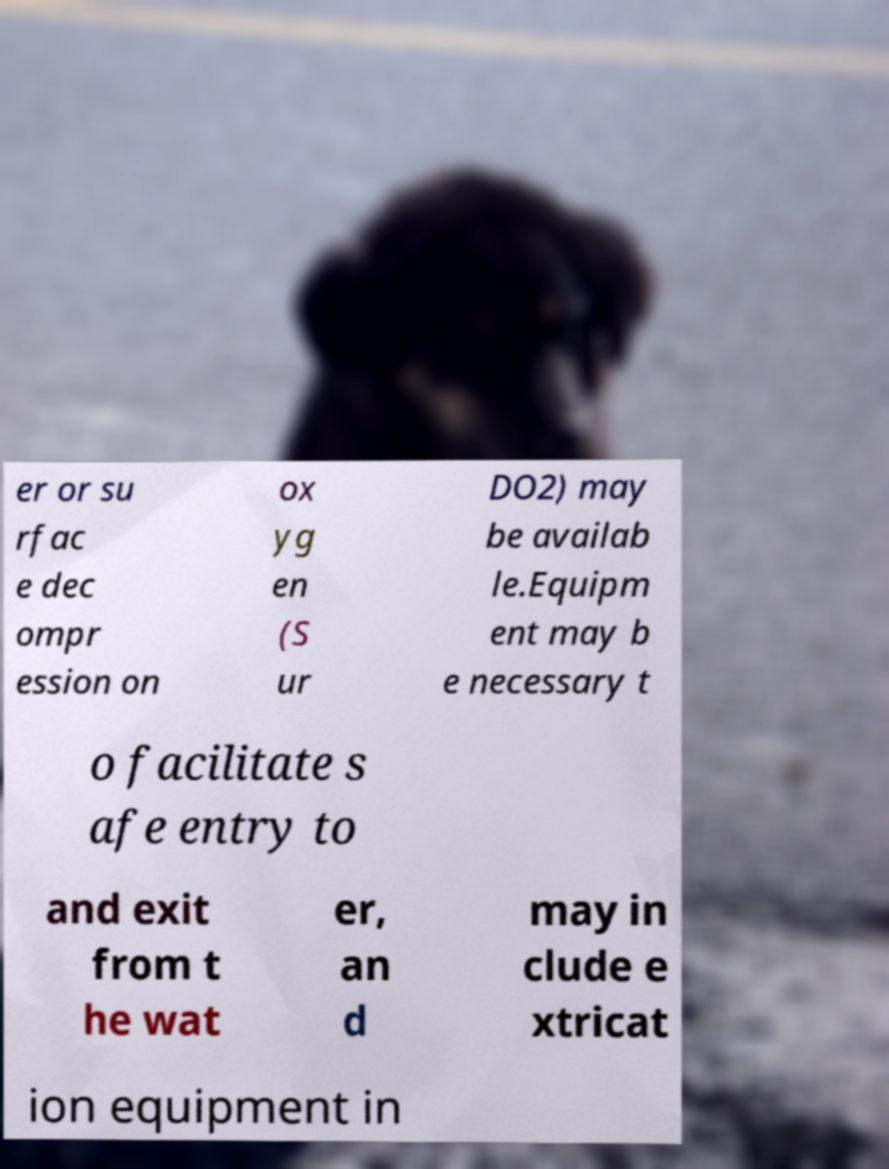Can you accurately transcribe the text from the provided image for me? er or su rfac e dec ompr ession on ox yg en (S ur DO2) may be availab le.Equipm ent may b e necessary t o facilitate s afe entry to and exit from t he wat er, an d may in clude e xtricat ion equipment in 